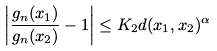<formula> <loc_0><loc_0><loc_500><loc_500>\left | \frac { g _ { n } ( x _ { 1 } ) } { g _ { n } ( x _ { 2 } ) } - 1 \right | \leq K _ { 2 } d ( x _ { 1 } , x _ { 2 } ) ^ { \alpha }</formula> 